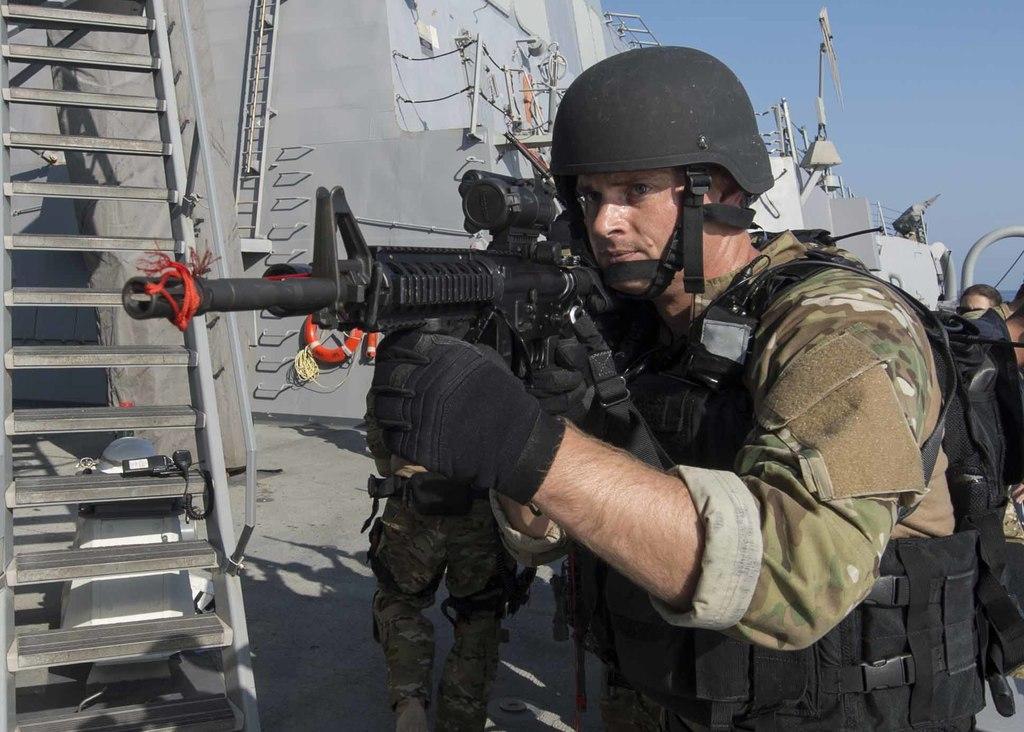Please provide a concise description of this image. In this image we can see a person wearing helmet and gloves and he is holding a gun. In the back there are few people. On the left side we can see ladder. In the back there are walls. Also there is a ladder. And there are railings and few other objects. And there is sky. 